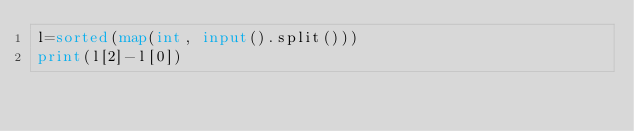<code> <loc_0><loc_0><loc_500><loc_500><_Python_>l=sorted(map(int, input().split()))
print(l[2]-l[0])
</code> 